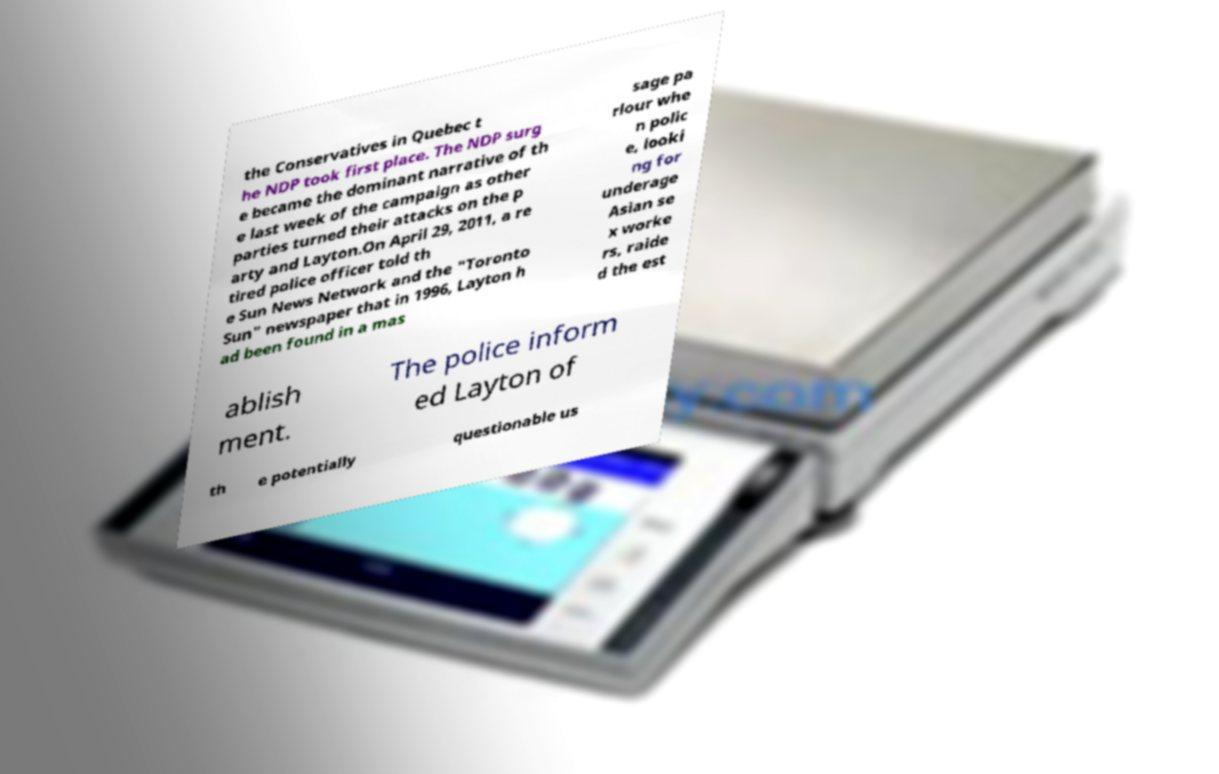There's text embedded in this image that I need extracted. Can you transcribe it verbatim? the Conservatives in Quebec t he NDP took first place. The NDP surg e became the dominant narrative of th e last week of the campaign as other parties turned their attacks on the p arty and Layton.On April 29, 2011, a re tired police officer told th e Sun News Network and the "Toronto Sun" newspaper that in 1996, Layton h ad been found in a mas sage pa rlour whe n polic e, looki ng for underage Asian se x worke rs, raide d the est ablish ment. The police inform ed Layton of th e potentially questionable us 